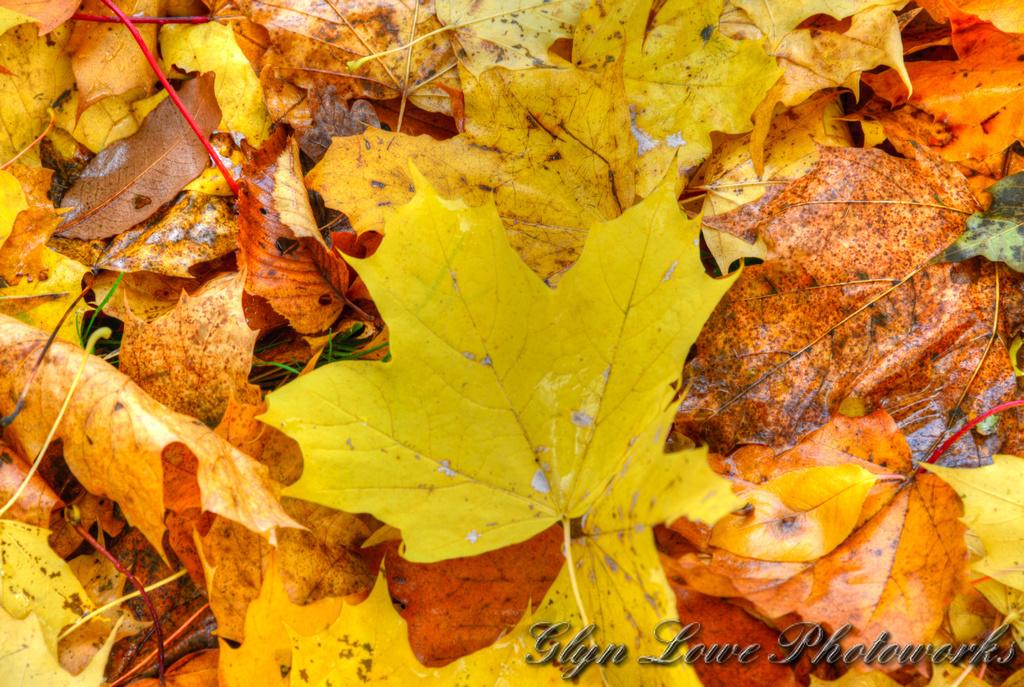What type of vegetation can be seen in the image? There are leaves in the image. What else is present in the image besides the leaves? There is text visible in the image. Can you hear the bell ringing in the image? There is no bell present in the image, so it cannot be heard. 